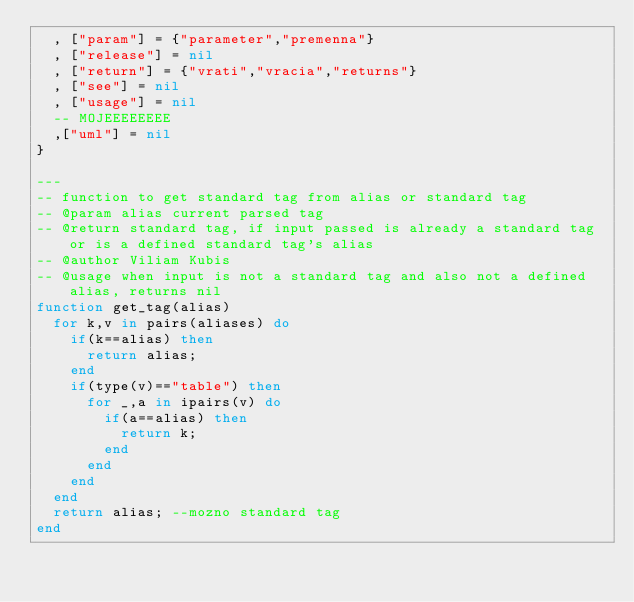Convert code to text. <code><loc_0><loc_0><loc_500><loc_500><_Lua_>	, ["param"] = {"parameter","premenna"}
	, ["release"] = nil
	, ["return"] = {"vrati","vracia","returns"}
	, ["see"] = nil
	, ["usage"] = nil
	-- MOJEEEEEEEE
	,["uml"] = nil
}

---
-- function to get standard tag from alias or standard tag
-- @param alias current parsed tag
-- @return standard tag, if input passed is already a standard tag or is a defined standard tag's alias
-- @author Viliam Kubis
-- @usage when input is not a standard tag and also not a defined alias, returns nil
function get_tag(alias)
	for k,v in pairs(aliases) do
		if(k==alias) then
			return alias;
		end
		if(type(v)=="table") then
			for _,a in ipairs(v) do
				if(a==alias) then
					return k;
				end
			end
		end
	end
	return alias; --mozno standard tag
end
</code> 